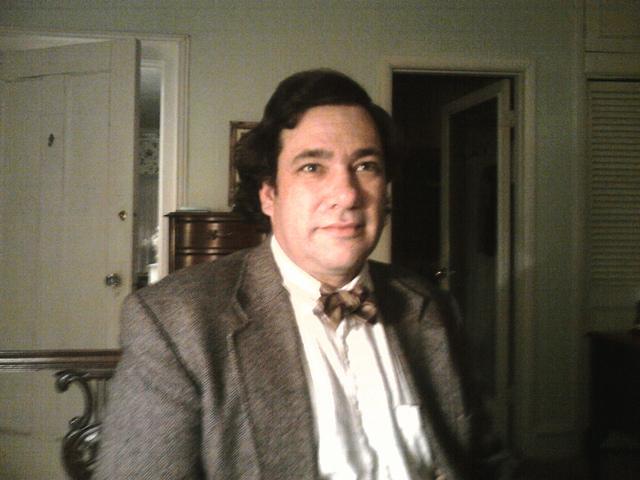What color is the man's bow tie?
Short answer required. Brown. What is he wearing around his neck?
Concise answer only. Bowtie. What color is the man's suit?
Concise answer only. Gray. Is his suit black?
Write a very short answer. No. What color bow tie is this person wearing?
Short answer required. Brown. What's behind the man?
Short answer required. Door. 